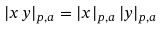<formula> <loc_0><loc_0><loc_500><loc_500>| x \, y | _ { p , a } = | x | _ { p , a } \, | y | _ { p , a }</formula> 